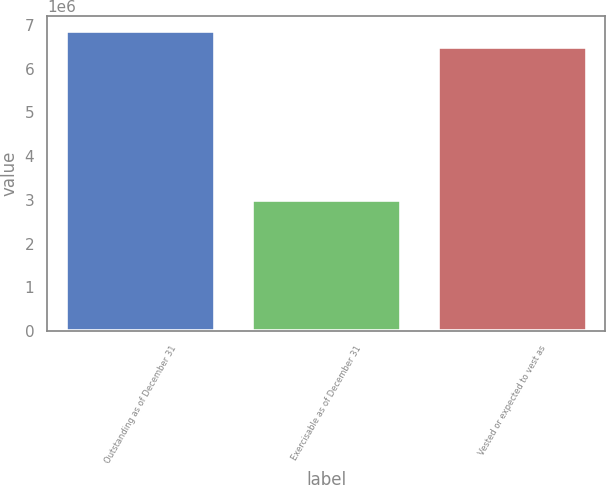Convert chart. <chart><loc_0><loc_0><loc_500><loc_500><bar_chart><fcel>Outstanding as of December 31<fcel>Exercisable as of December 31<fcel>Vested or expected to vest as<nl><fcel>6.8578e+06<fcel>2.99225e+06<fcel>6.50618e+06<nl></chart> 